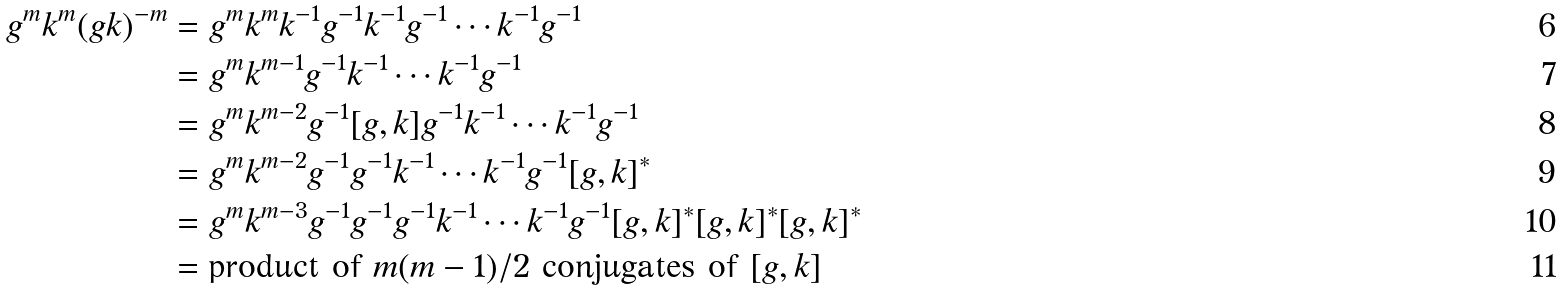Convert formula to latex. <formula><loc_0><loc_0><loc_500><loc_500>g ^ { m } k ^ { m } ( g k ) ^ { - m } & = g ^ { m } k ^ { m } k ^ { - 1 } g ^ { - 1 } k ^ { - 1 } g ^ { - 1 } \cdots k ^ { - 1 } g ^ { - 1 } \\ & = g ^ { m } k ^ { m - 1 } g ^ { - 1 } k ^ { - 1 } \cdots k ^ { - 1 } g ^ { - 1 } \\ & = g ^ { m } k ^ { m - 2 } g ^ { - 1 } [ g , k ] g ^ { - 1 } k ^ { - 1 } \cdots k ^ { - 1 } g ^ { - 1 } \\ & = g ^ { m } k ^ { m - 2 } g ^ { - 1 } g ^ { - 1 } k ^ { - 1 } \cdots k ^ { - 1 } g ^ { - 1 } [ g , k ] ^ { * } \\ & = g ^ { m } k ^ { m - 3 } g ^ { - 1 } g ^ { - 1 } g ^ { - 1 } k ^ { - 1 } \cdots k ^ { - 1 } g ^ { - 1 } [ g , k ] ^ { * } [ g , k ] ^ { * } [ g , k ] ^ { * } \\ & = \text {product of } m ( m - 1 ) / 2 \text { conjugates of } [ g , k ]</formula> 